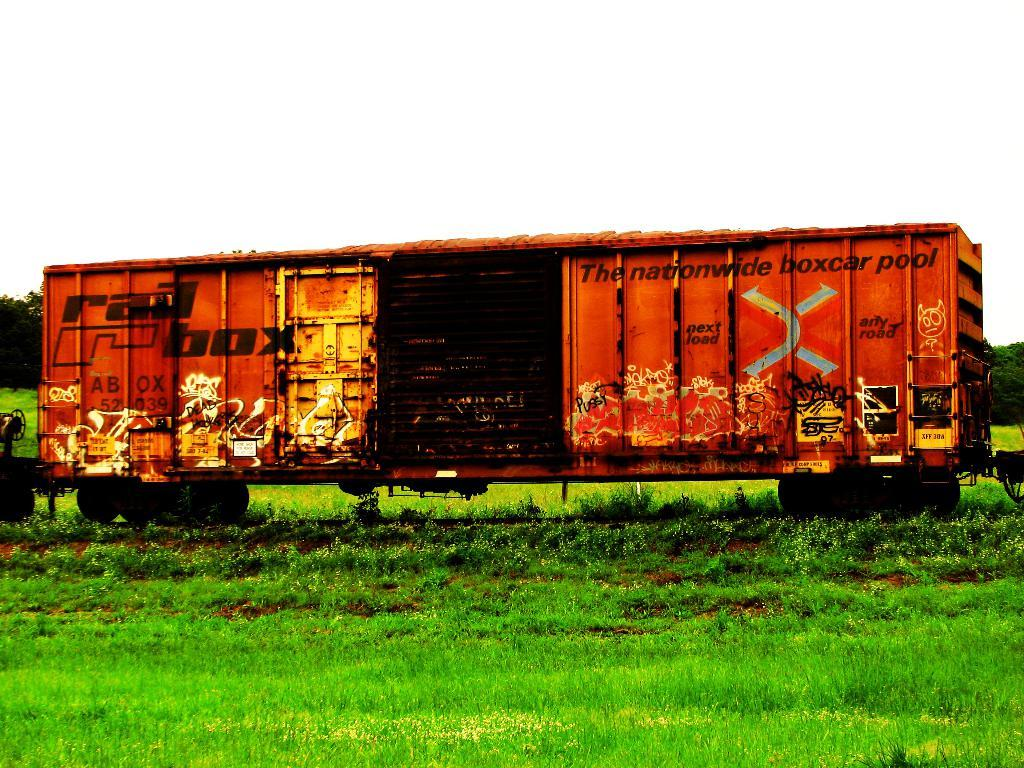What type of surface is at the bottom of the image? There is grass at the bottom of the image. What can be seen in the middle of the image? There is a compartment of a train on a railway track. What type of vegetation is visible in the background of the image? There are trees and grass in the background of the image. What is visible in the background of the image besides vegetation? The sky is visible in the background of the image. Can you see any cherries growing on the trees in the image? There is no mention of cherries or any fruit trees in the image; it features grass, a train compartment, trees, and the sky. Is there a whip visible in the image? There is no whip present in the image. 